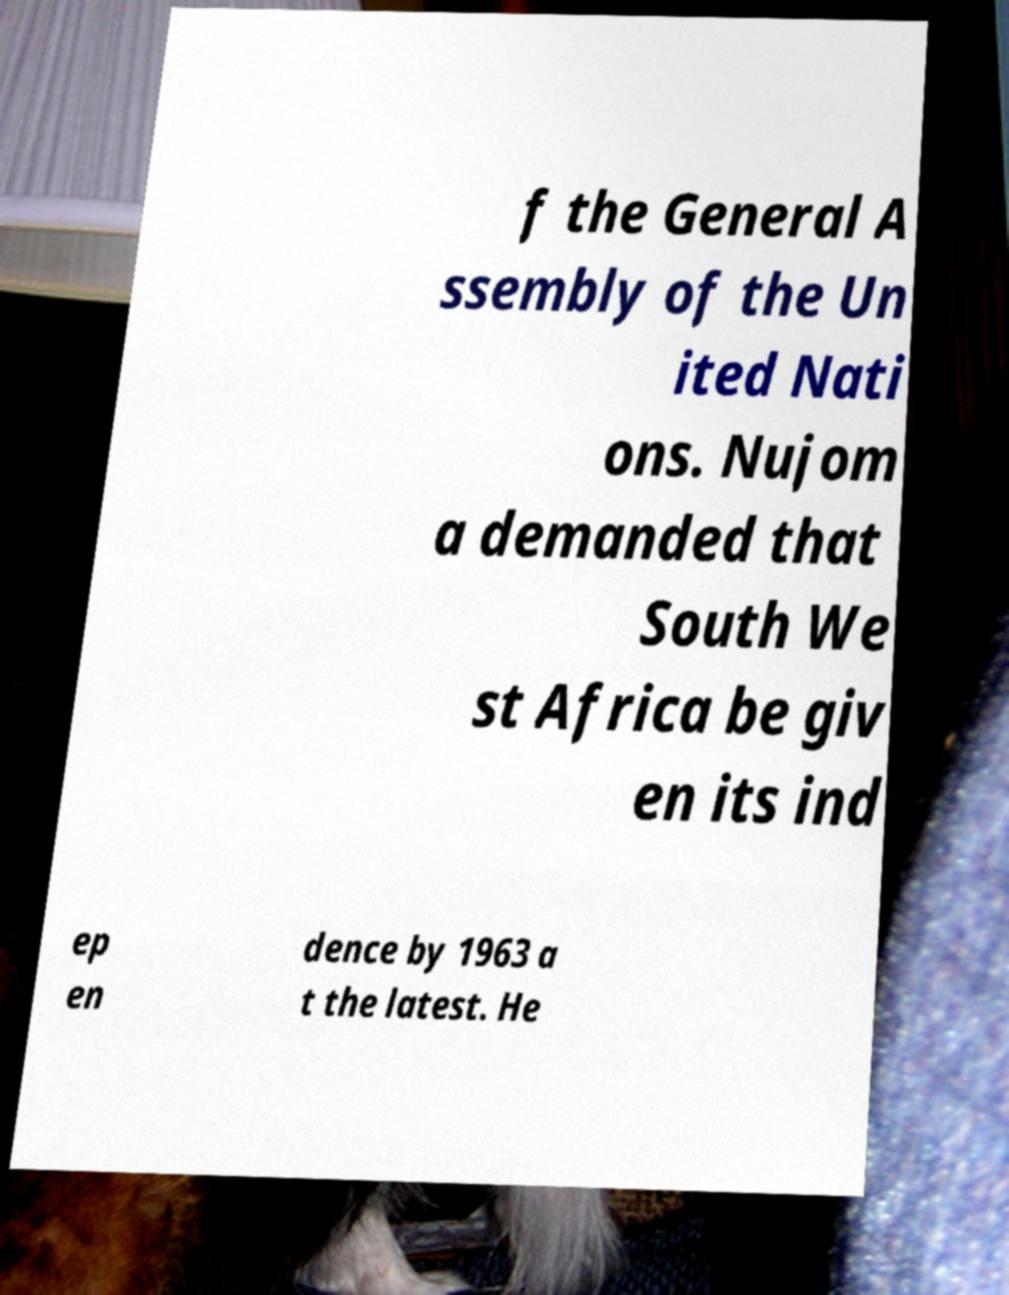Can you read and provide the text displayed in the image?This photo seems to have some interesting text. Can you extract and type it out for me? f the General A ssembly of the Un ited Nati ons. Nujom a demanded that South We st Africa be giv en its ind ep en dence by 1963 a t the latest. He 